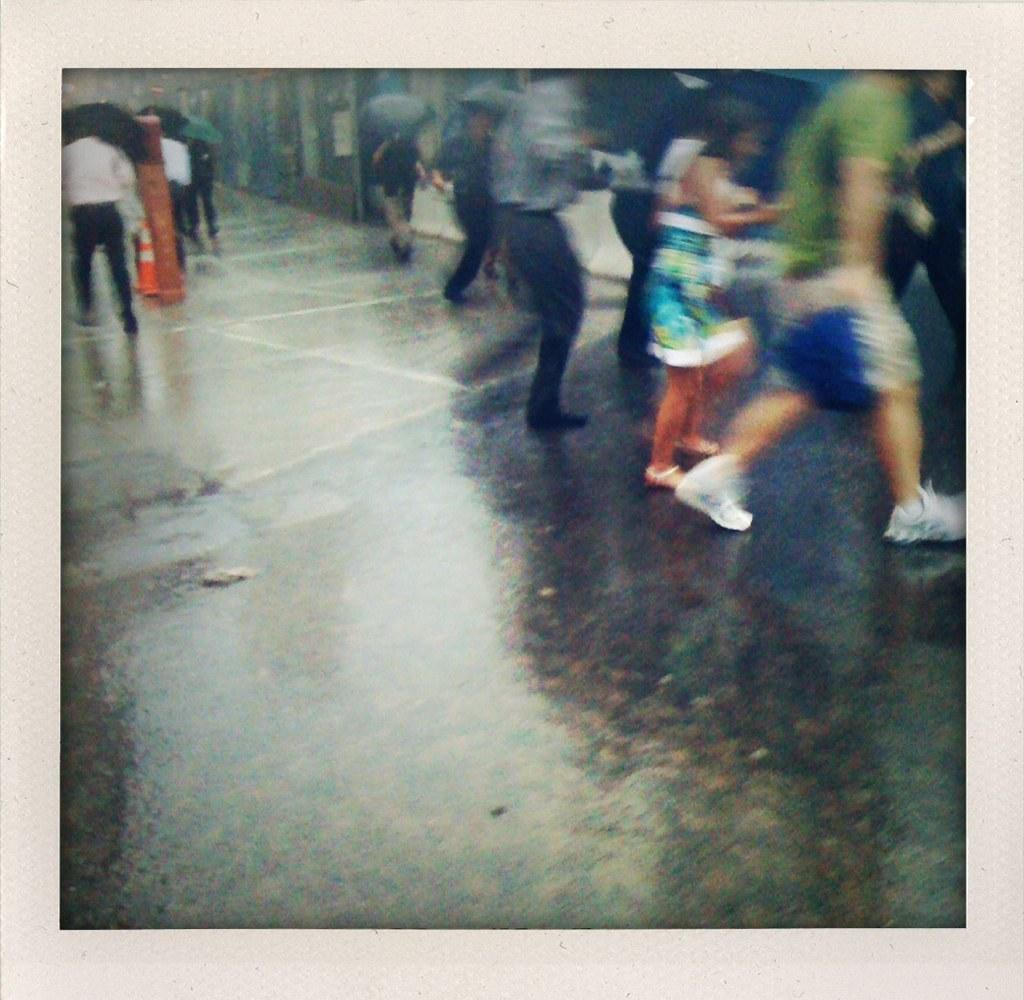What are the people in the image doing? The people in the image are on the road and holding umbrellas. What objects can be seen in the image besides the people? There is a pole and a traffic cone in the image. What is visible in the background of the image? There is a wall in the background of the image. What type of calendar is hanging on the wall in the image? There is no calendar visible in the image; only a wall is present in the background. 